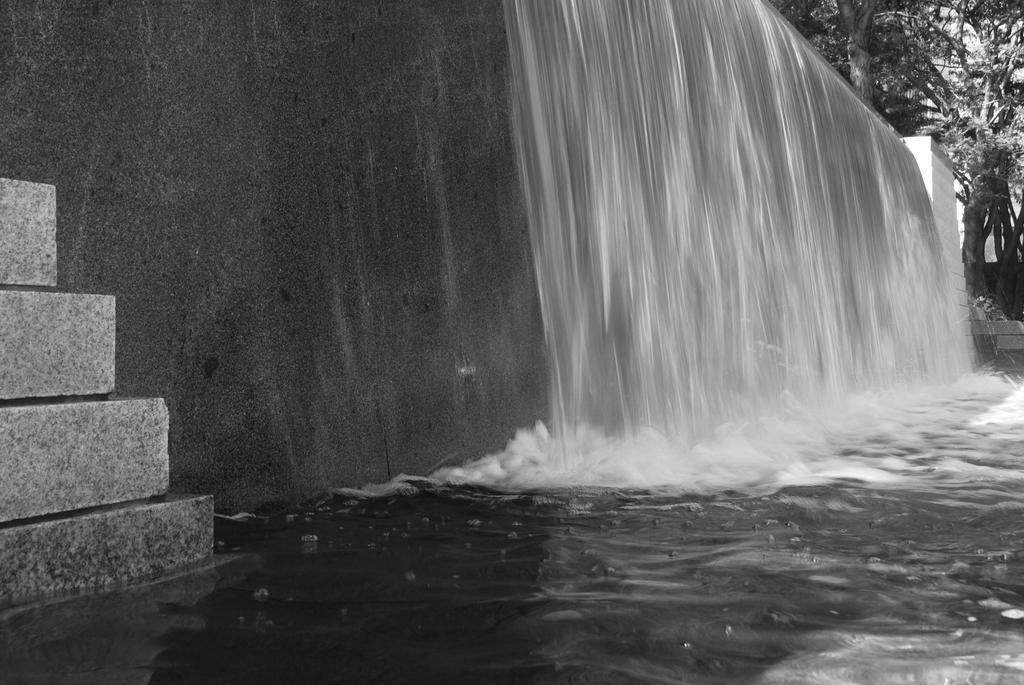What natural feature is the main subject of the image? There is a waterfall in the image. What can be seen in the distance behind the waterfall? There is a building and trees in the background of the image. What is visible at the bottom of the image? There is water visible at the bottom of the image. What type of agreement was reached between the tank and the school in the image? There is no tank or school present in the image; it features a waterfall and background elements. 